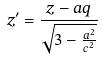Convert formula to latex. <formula><loc_0><loc_0><loc_500><loc_500>z ^ { \prime } = \frac { z - a q } { \sqrt { 3 - \frac { a ^ { 2 } } { c ^ { 2 } } } }</formula> 